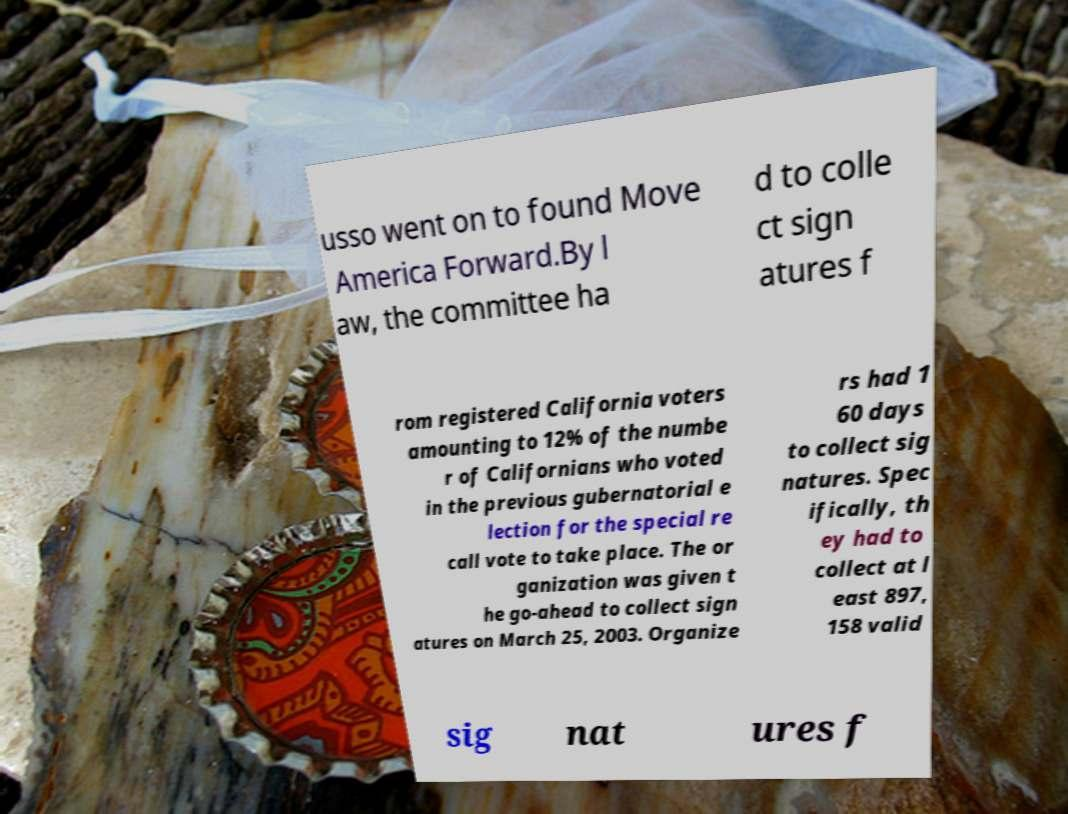Could you assist in decoding the text presented in this image and type it out clearly? usso went on to found Move America Forward.By l aw, the committee ha d to colle ct sign atures f rom registered California voters amounting to 12% of the numbe r of Californians who voted in the previous gubernatorial e lection for the special re call vote to take place. The or ganization was given t he go-ahead to collect sign atures on March 25, 2003. Organize rs had 1 60 days to collect sig natures. Spec ifically, th ey had to collect at l east 897, 158 valid sig nat ures f 